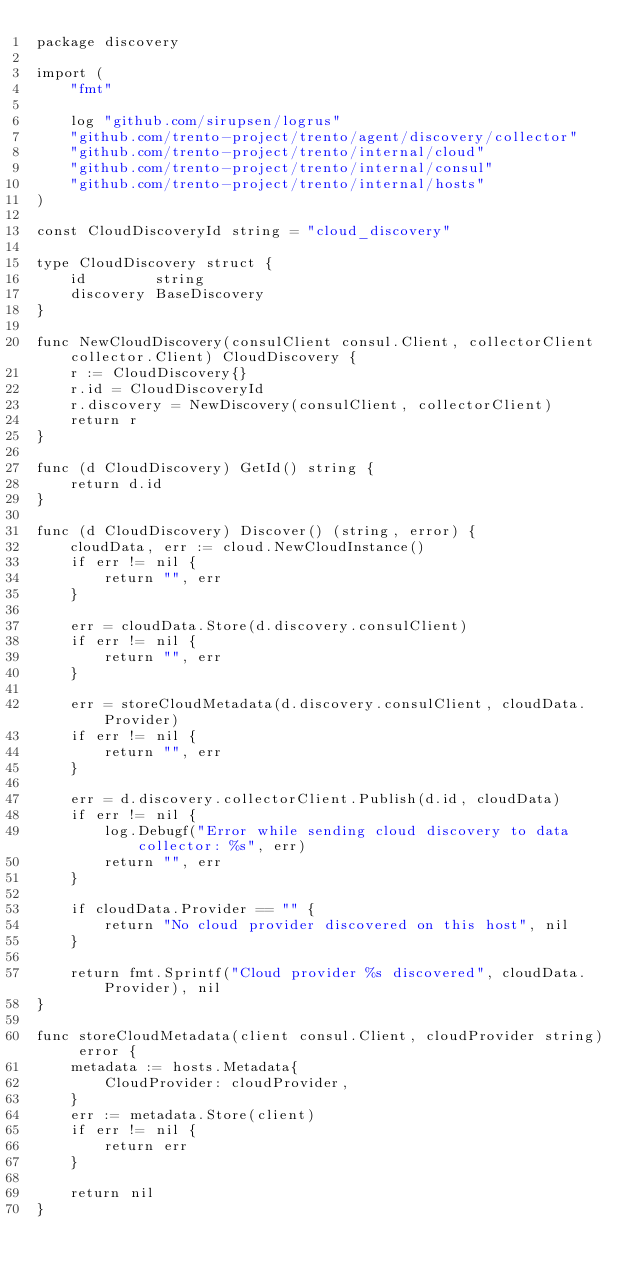Convert code to text. <code><loc_0><loc_0><loc_500><loc_500><_Go_>package discovery

import (
	"fmt"

	log "github.com/sirupsen/logrus"
	"github.com/trento-project/trento/agent/discovery/collector"
	"github.com/trento-project/trento/internal/cloud"
	"github.com/trento-project/trento/internal/consul"
	"github.com/trento-project/trento/internal/hosts"
)

const CloudDiscoveryId string = "cloud_discovery"

type CloudDiscovery struct {
	id        string
	discovery BaseDiscovery
}

func NewCloudDiscovery(consulClient consul.Client, collectorClient collector.Client) CloudDiscovery {
	r := CloudDiscovery{}
	r.id = CloudDiscoveryId
	r.discovery = NewDiscovery(consulClient, collectorClient)
	return r
}

func (d CloudDiscovery) GetId() string {
	return d.id
}

func (d CloudDiscovery) Discover() (string, error) {
	cloudData, err := cloud.NewCloudInstance()
	if err != nil {
		return "", err
	}

	err = cloudData.Store(d.discovery.consulClient)
	if err != nil {
		return "", err
	}

	err = storeCloudMetadata(d.discovery.consulClient, cloudData.Provider)
	if err != nil {
		return "", err
	}

	err = d.discovery.collectorClient.Publish(d.id, cloudData)
	if err != nil {
		log.Debugf("Error while sending cloud discovery to data collector: %s", err)
		return "", err
	}

	if cloudData.Provider == "" {
		return "No cloud provider discovered on this host", nil
	}

	return fmt.Sprintf("Cloud provider %s discovered", cloudData.Provider), nil
}

func storeCloudMetadata(client consul.Client, cloudProvider string) error {
	metadata := hosts.Metadata{
		CloudProvider: cloudProvider,
	}
	err := metadata.Store(client)
	if err != nil {
		return err
	}

	return nil
}
</code> 